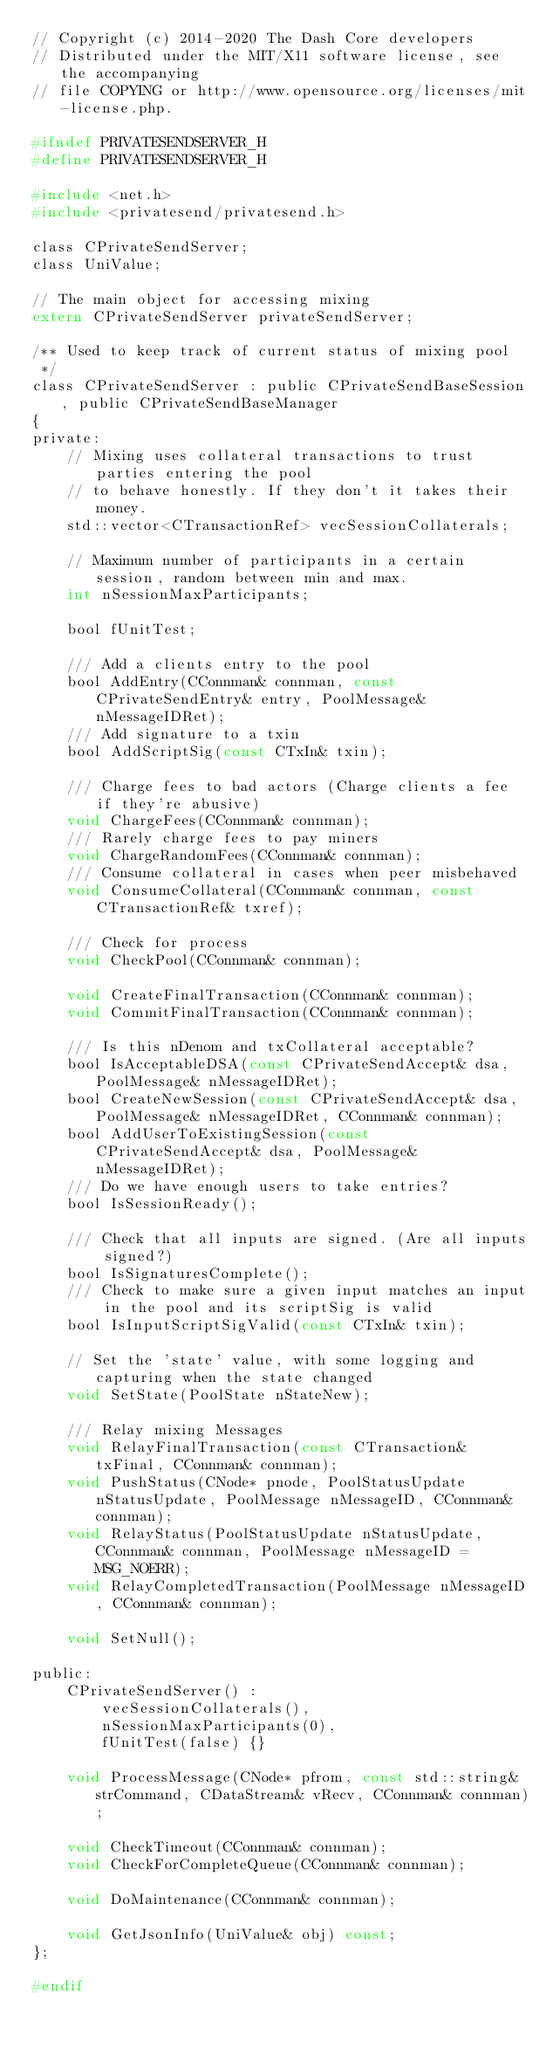<code> <loc_0><loc_0><loc_500><loc_500><_C_>// Copyright (c) 2014-2020 The Dash Core developers
// Distributed under the MIT/X11 software license, see the accompanying
// file COPYING or http://www.opensource.org/licenses/mit-license.php.

#ifndef PRIVATESENDSERVER_H
#define PRIVATESENDSERVER_H

#include <net.h>
#include <privatesend/privatesend.h>

class CPrivateSendServer;
class UniValue;

// The main object for accessing mixing
extern CPrivateSendServer privateSendServer;

/** Used to keep track of current status of mixing pool
 */
class CPrivateSendServer : public CPrivateSendBaseSession, public CPrivateSendBaseManager
{
private:
    // Mixing uses collateral transactions to trust parties entering the pool
    // to behave honestly. If they don't it takes their money.
    std::vector<CTransactionRef> vecSessionCollaterals;

    // Maximum number of participants in a certain session, random between min and max.
    int nSessionMaxParticipants;

    bool fUnitTest;

    /// Add a clients entry to the pool
    bool AddEntry(CConnman& connman, const CPrivateSendEntry& entry, PoolMessage& nMessageIDRet);
    /// Add signature to a txin
    bool AddScriptSig(const CTxIn& txin);

    /// Charge fees to bad actors (Charge clients a fee if they're abusive)
    void ChargeFees(CConnman& connman);
    /// Rarely charge fees to pay miners
    void ChargeRandomFees(CConnman& connman);
    /// Consume collateral in cases when peer misbehaved
    void ConsumeCollateral(CConnman& connman, const CTransactionRef& txref);

    /// Check for process
    void CheckPool(CConnman& connman);

    void CreateFinalTransaction(CConnman& connman);
    void CommitFinalTransaction(CConnman& connman);

    /// Is this nDenom and txCollateral acceptable?
    bool IsAcceptableDSA(const CPrivateSendAccept& dsa, PoolMessage& nMessageIDRet);
    bool CreateNewSession(const CPrivateSendAccept& dsa, PoolMessage& nMessageIDRet, CConnman& connman);
    bool AddUserToExistingSession(const CPrivateSendAccept& dsa, PoolMessage& nMessageIDRet);
    /// Do we have enough users to take entries?
    bool IsSessionReady();

    /// Check that all inputs are signed. (Are all inputs signed?)
    bool IsSignaturesComplete();
    /// Check to make sure a given input matches an input in the pool and its scriptSig is valid
    bool IsInputScriptSigValid(const CTxIn& txin);

    // Set the 'state' value, with some logging and capturing when the state changed
    void SetState(PoolState nStateNew);

    /// Relay mixing Messages
    void RelayFinalTransaction(const CTransaction& txFinal, CConnman& connman);
    void PushStatus(CNode* pnode, PoolStatusUpdate nStatusUpdate, PoolMessage nMessageID, CConnman& connman);
    void RelayStatus(PoolStatusUpdate nStatusUpdate, CConnman& connman, PoolMessage nMessageID = MSG_NOERR);
    void RelayCompletedTransaction(PoolMessage nMessageID, CConnman& connman);

    void SetNull();

public:
    CPrivateSendServer() :
        vecSessionCollaterals(),
        nSessionMaxParticipants(0),
        fUnitTest(false) {}

    void ProcessMessage(CNode* pfrom, const std::string& strCommand, CDataStream& vRecv, CConnman& connman);

    void CheckTimeout(CConnman& connman);
    void CheckForCompleteQueue(CConnman& connman);

    void DoMaintenance(CConnman& connman);

    void GetJsonInfo(UniValue& obj) const;
};

#endif
</code> 